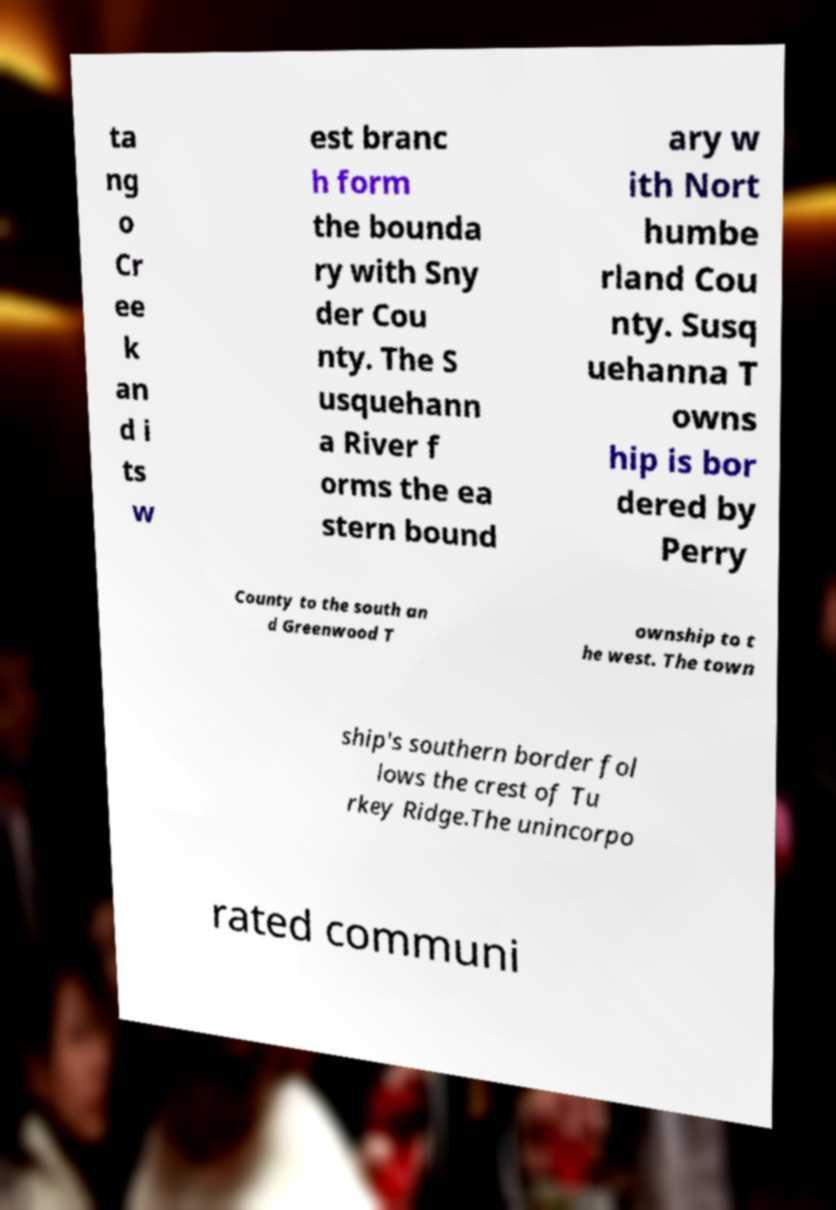Can you read and provide the text displayed in the image?This photo seems to have some interesting text. Can you extract and type it out for me? ta ng o Cr ee k an d i ts w est branc h form the bounda ry with Sny der Cou nty. The S usquehann a River f orms the ea stern bound ary w ith Nort humbe rland Cou nty. Susq uehanna T owns hip is bor dered by Perry County to the south an d Greenwood T ownship to t he west. The town ship's southern border fol lows the crest of Tu rkey Ridge.The unincorpo rated communi 